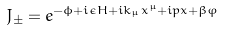<formula> <loc_0><loc_0><loc_500><loc_500>J _ { \pm } = e ^ { - \phi + i \epsilon H + i k _ { \mu } x ^ { \mu } + i p x + \beta \varphi }</formula> 